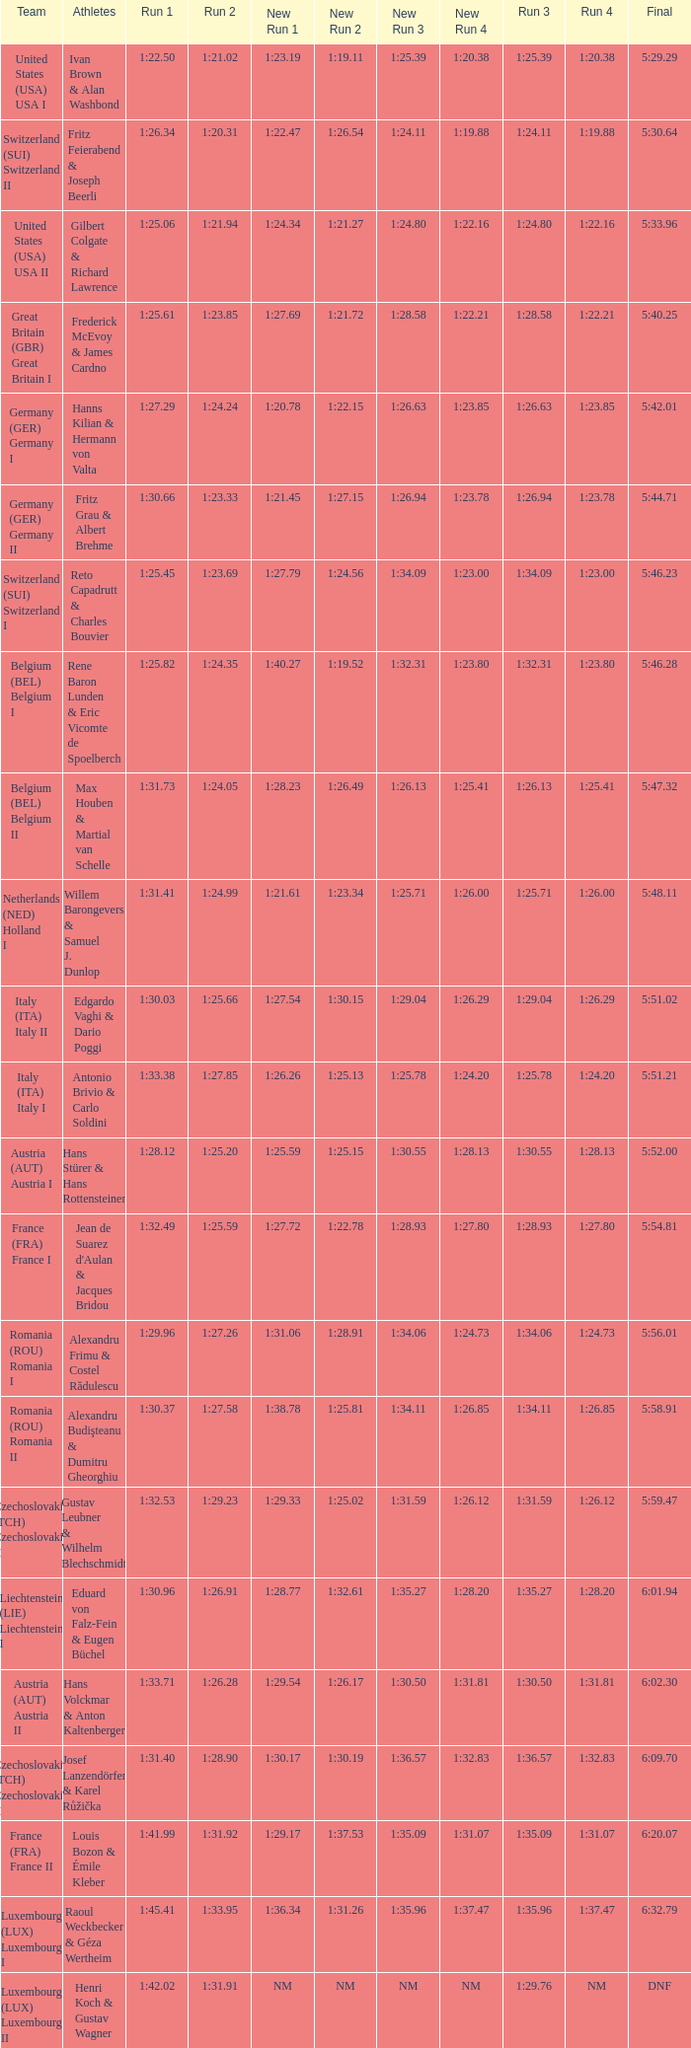Which Run 2 has a Run 1 of 1:30.03? 1:25.66. 